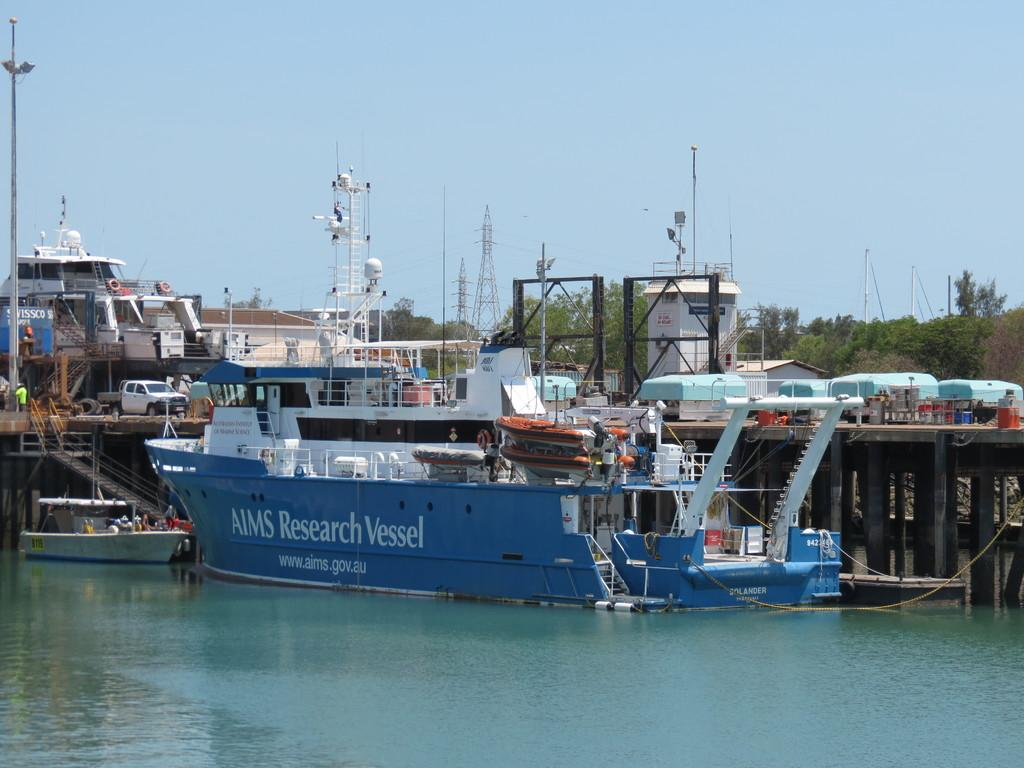What is the main subject in the center of the image? There is a ship in the center of the image. What is the ship's location in relation to the water? The ship is on the water. What structures can be seen in the background of the image? There are pillars, a bridge, containers, other ships, a vehicle, a boat, trees, towers, and the sky visible in the background of the image. How many ships are visible in the image? There is one ship in the center and other ships in the background, making a total of at least two ships visible. What type of clam is being used as a territory marker by the queen in the image? There is no clam, territory, or queen present in the image. 